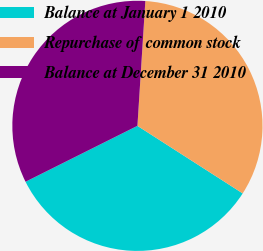<chart> <loc_0><loc_0><loc_500><loc_500><pie_chart><fcel>Balance at January 1 2010<fcel>Repurchase of common stock<fcel>Balance at December 31 2010<nl><fcel>33.54%<fcel>33.07%<fcel>33.38%<nl></chart> 